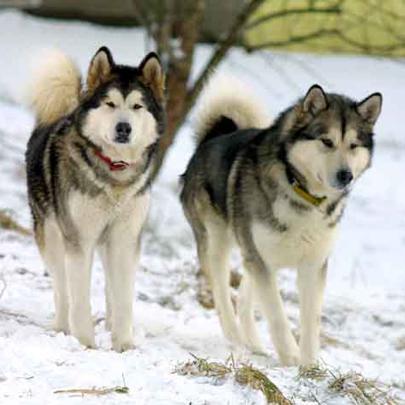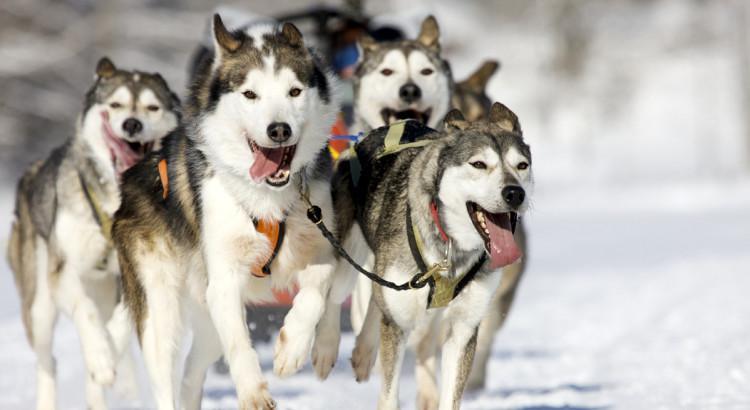The first image is the image on the left, the second image is the image on the right. Evaluate the accuracy of this statement regarding the images: "One of the images contains one Husky dog and the other image contains two Husky dogs.". Is it true? Answer yes or no. No. The first image is the image on the left, the second image is the image on the right. Given the left and right images, does the statement "One image features a dog sitting upright to the right of a dog in a reclining pose, and the other image includes a dog with snow on its fur." hold true? Answer yes or no. No. 